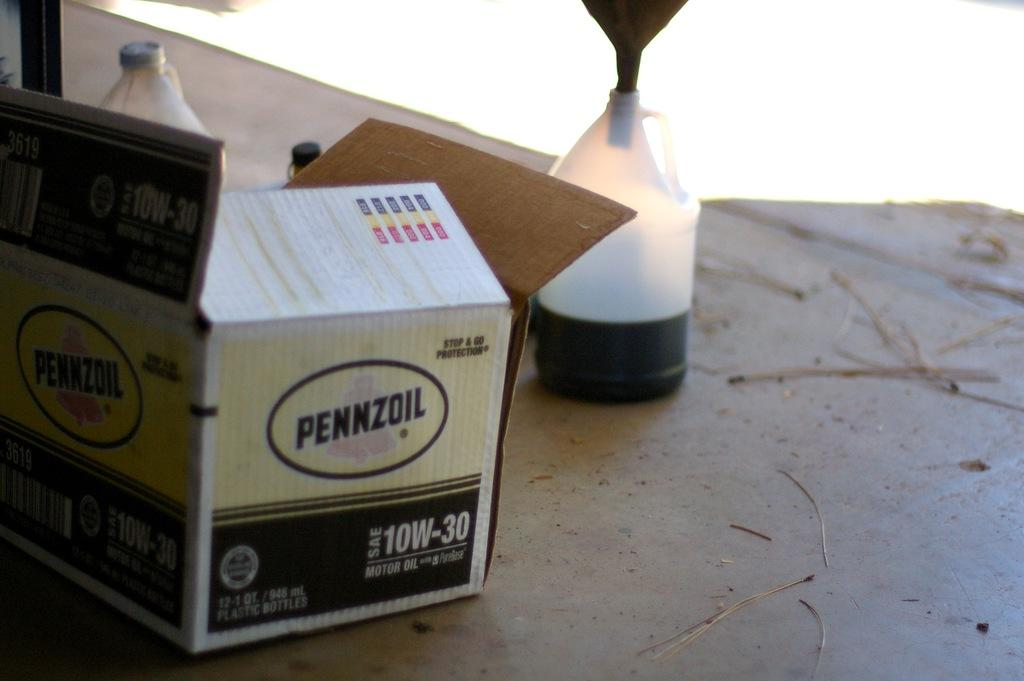<image>
Summarize the visual content of the image. Pennzoil 10W-30 is printed on the side of this box. 